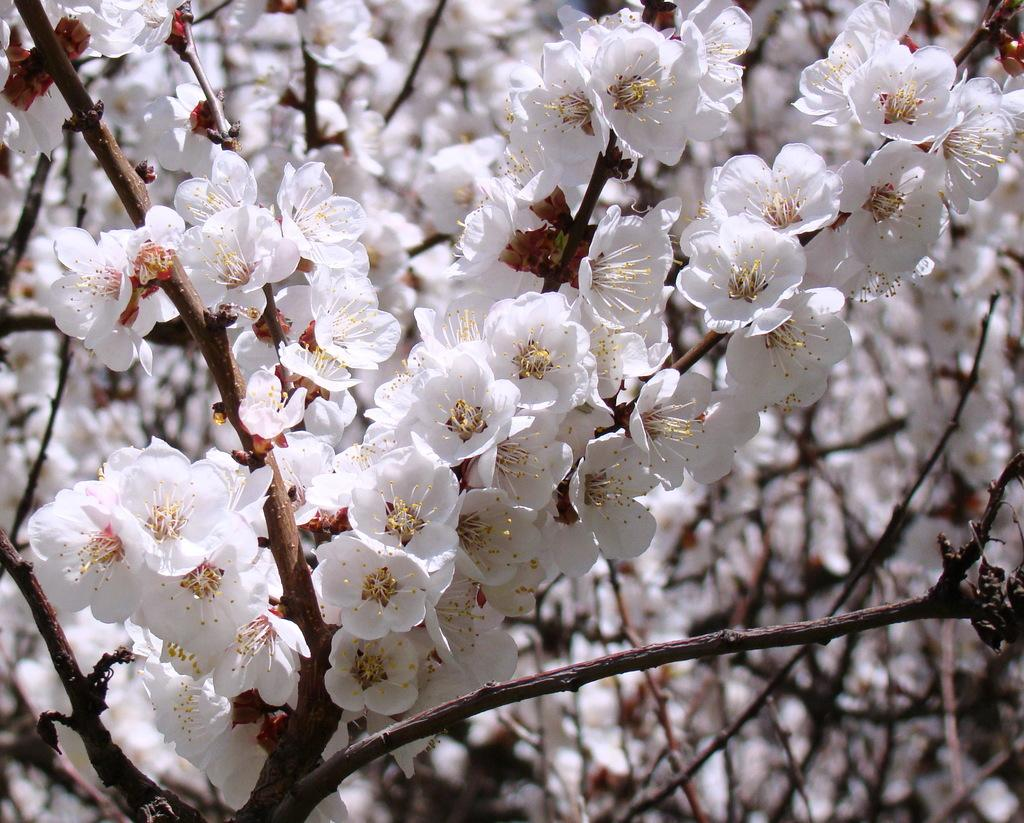What type of flowers are depicted in the image? There are blossoms in the image. What is the level of pollution in the image? There is no information about pollution in the image, as it only features blossoms. Can you hear the flowers laughing in the image? There is no sound or indication of laughter in the image, as it only features blossoms. 